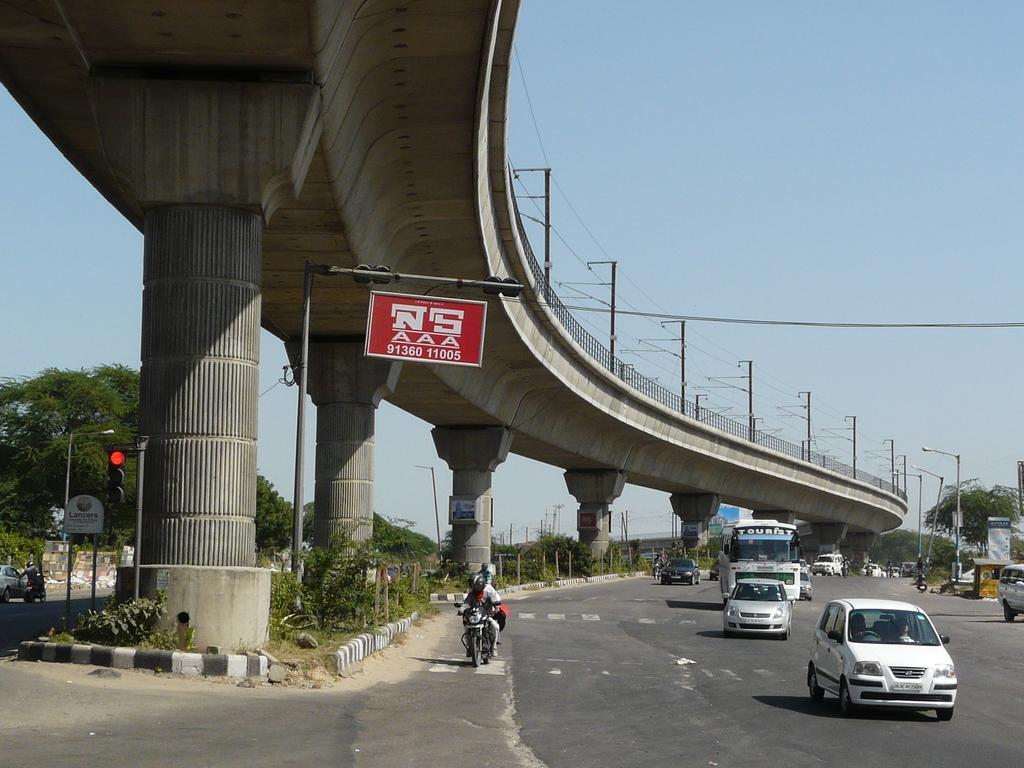Could you give a brief overview of what you see in this image? In this picture there is a flyover which has few poles and wires above it and there are few plants and a traffic signal below it and there are few vehicles and trees on either sides of it. 